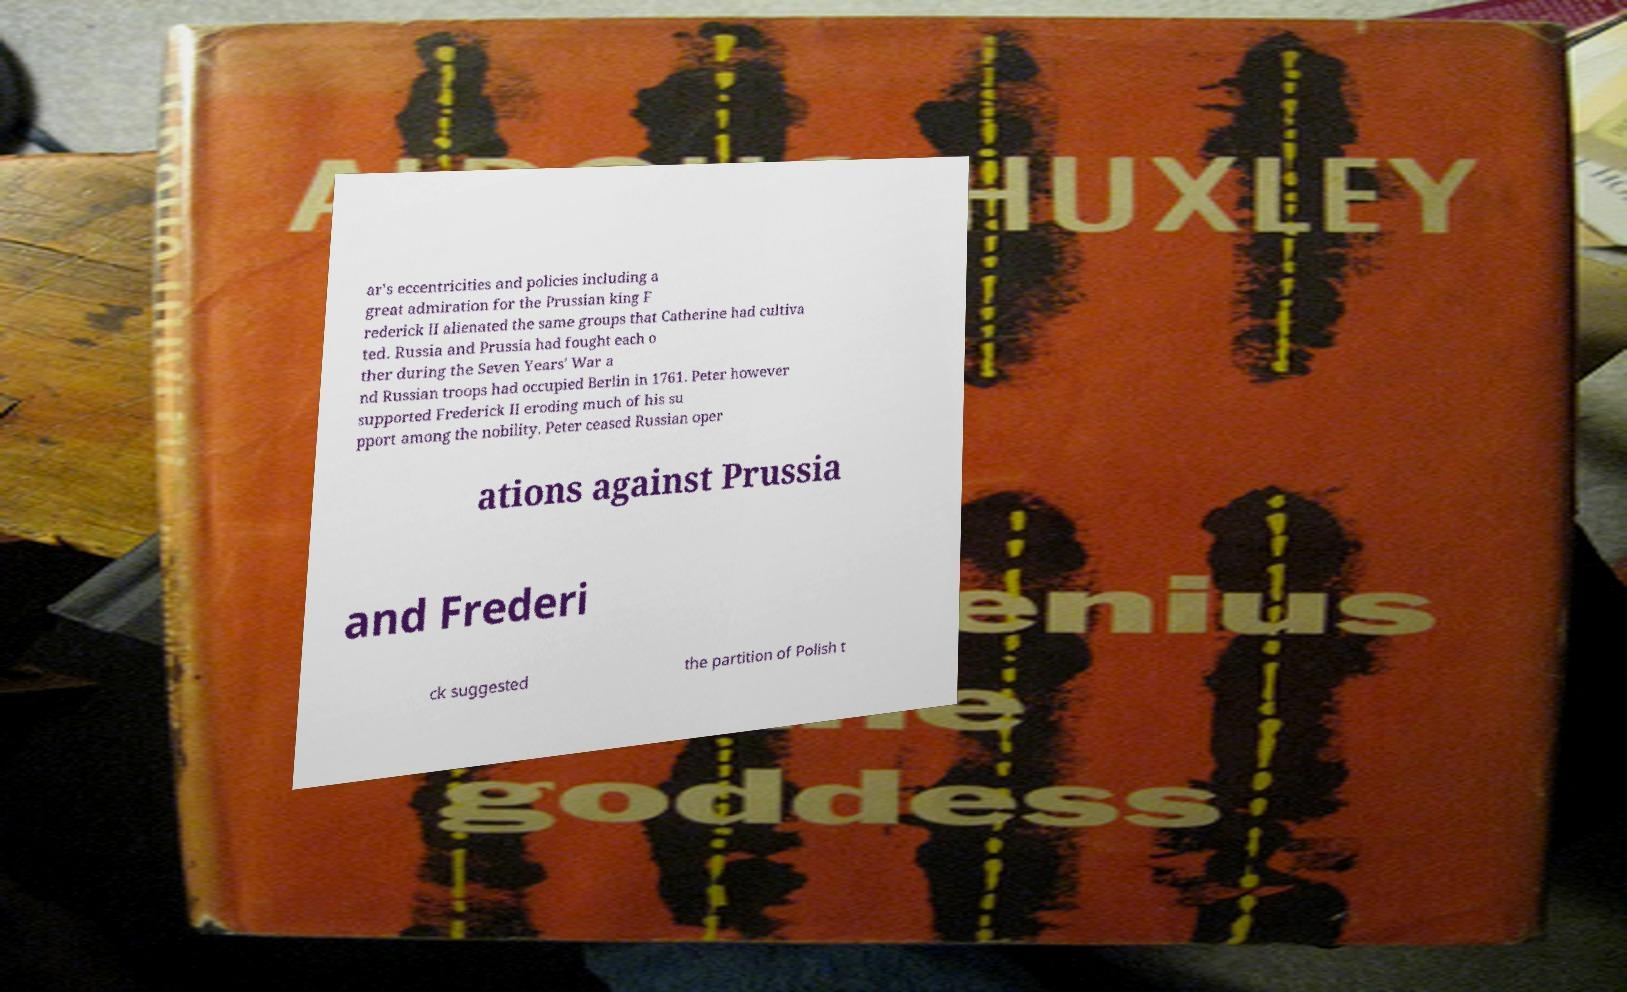What messages or text are displayed in this image? I need them in a readable, typed format. ar's eccentricities and policies including a great admiration for the Prussian king F rederick II alienated the same groups that Catherine had cultiva ted. Russia and Prussia had fought each o ther during the Seven Years' War a nd Russian troops had occupied Berlin in 1761. Peter however supported Frederick II eroding much of his su pport among the nobility. Peter ceased Russian oper ations against Prussia and Frederi ck suggested the partition of Polish t 